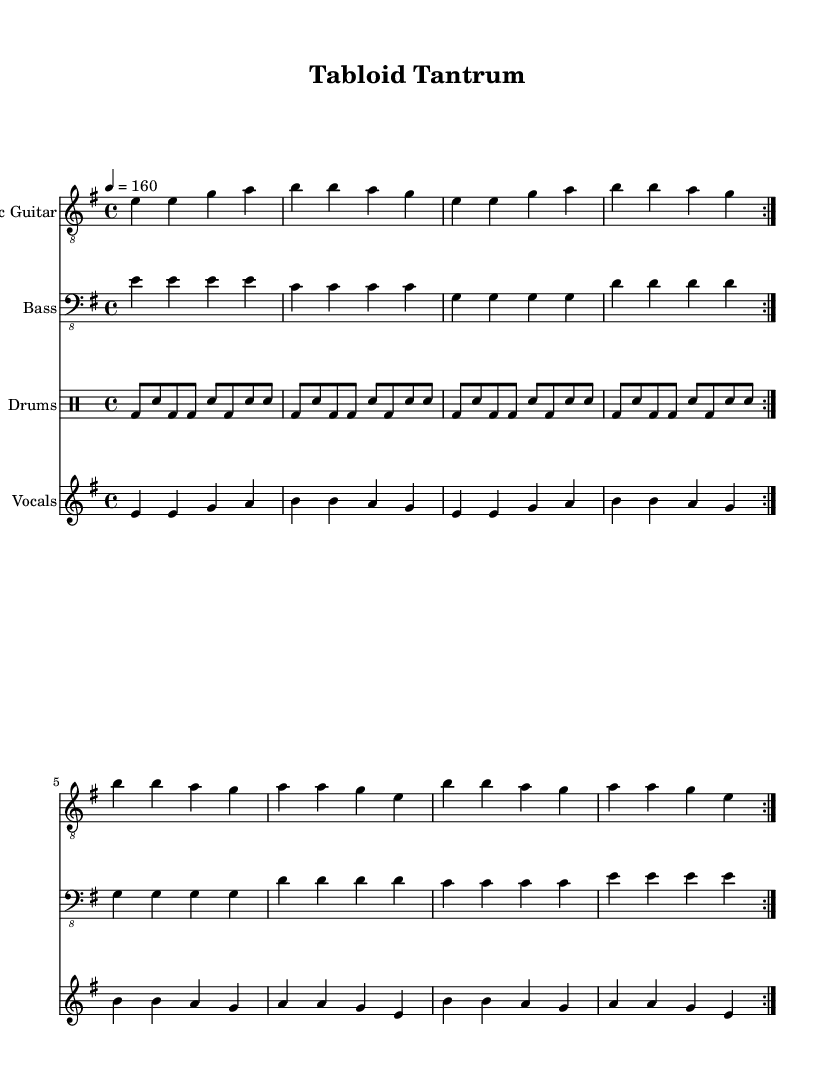What is the key signature of this music? The key signature is E minor, which contains one sharp (F#). This can be identified by looking at the key signature section at the beginning of the music sheet.
Answer: E minor What is the time signature of this piece? The time signature shown is 4/4, which indicates four beats in each measure and a quarter note receives one beat. This is represented at the beginning of the music sheet where the time signature is displayed.
Answer: 4/4 What is the tempo marking for this track? The tempo marking states that the piece should be played at 160 beats per minute, indicated with "4 = 160" in the tempo section.
Answer: 160 How many times is the guitar part repeated? The guitar part is repeated twice, as indicated by the "repeat volta 2" instruction found above the electric guitar section.
Answer: 2 In which section do the lyrics mention "Tabloid tantrum"? The lyrics mention "Tabloid tantrum" in the chorus, which is identified as the part that follows after the verse, indicated by its formatting in the sheet music.
Answer: Chorus How many measures are in the verse section? The verse section consists of 8 measures, as can be counted in the electric guitar and vocals parts labeled before the chorus begins, each section containing 4 measures repeated twice.
Answer: 8 